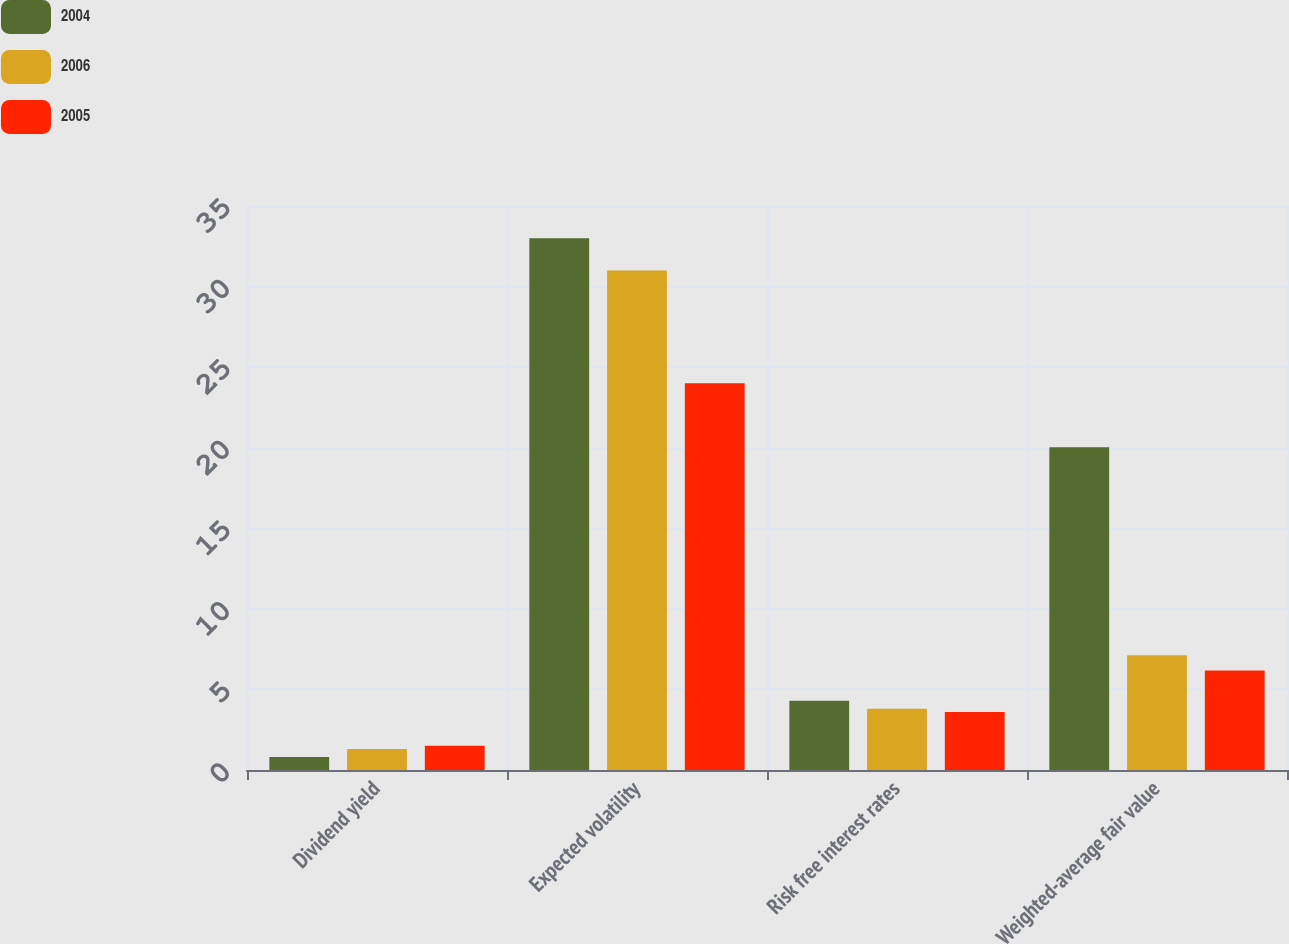Convert chart to OTSL. <chart><loc_0><loc_0><loc_500><loc_500><stacked_bar_chart><ecel><fcel>Dividend yield<fcel>Expected volatility<fcel>Risk free interest rates<fcel>Weighted-average fair value<nl><fcel>2004<fcel>0.8<fcel>33<fcel>4.3<fcel>20.03<nl><fcel>2006<fcel>1.3<fcel>31<fcel>3.8<fcel>7.12<nl><fcel>2005<fcel>1.5<fcel>24<fcel>3.6<fcel>6.17<nl></chart> 